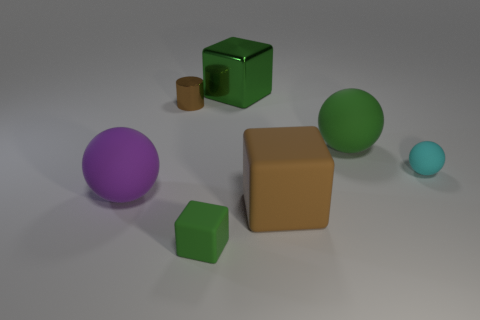Is the number of big cubes behind the small cyan rubber ball greater than the number of tiny cylinders that are behind the green metallic object?
Offer a very short reply. Yes. The brown object that is behind the green matte thing that is behind the small rubber thing that is on the right side of the big green shiny cube is made of what material?
Make the answer very short. Metal. There is a object that is made of the same material as the small cylinder; what shape is it?
Ensure brevity in your answer.  Cube. Are there any green rubber balls that are on the left side of the small block that is in front of the brown rubber cube?
Provide a succinct answer. No. How big is the purple thing?
Provide a succinct answer. Large. How many objects are large purple spheres or yellow things?
Offer a very short reply. 1. Are the cube that is in front of the brown matte cube and the big green thing that is in front of the shiny cube made of the same material?
Ensure brevity in your answer.  Yes. What color is the other big ball that is made of the same material as the big purple ball?
Ensure brevity in your answer.  Green. What number of rubber balls have the same size as the brown matte object?
Give a very brief answer. 2. What number of other things are there of the same color as the shiny block?
Offer a very short reply. 2. 